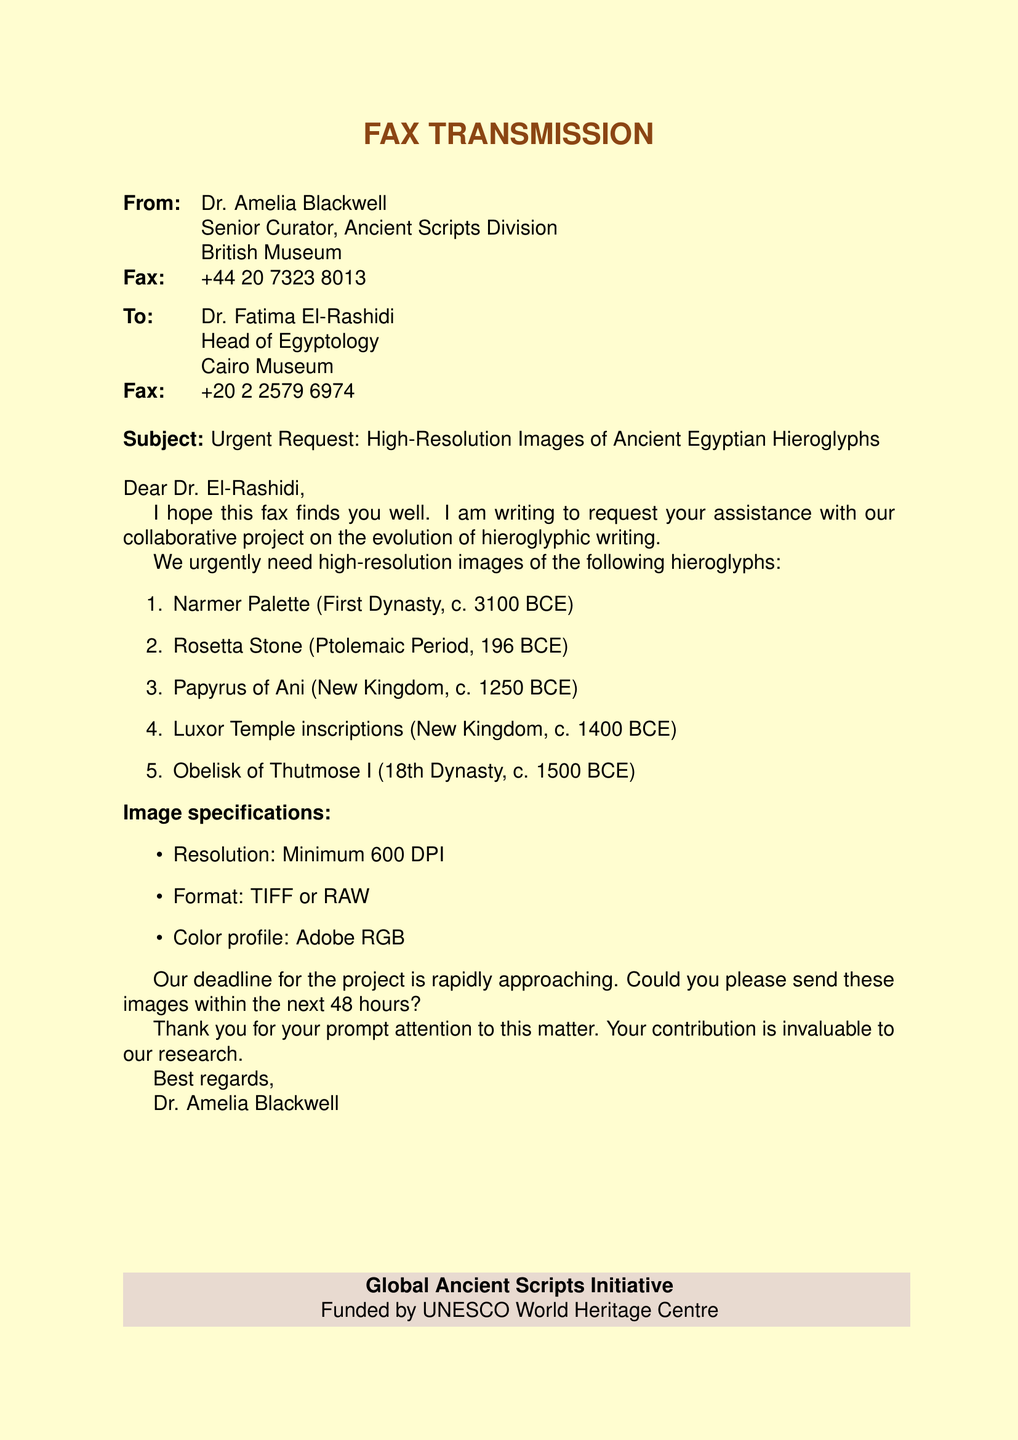What is the subject of the fax? The subject line indicates the main topic being discussed in the fax, which is an urgent request for images.
Answer: Urgent Request: High-Resolution Images of Ancient Egyptian Hieroglyphs Who is the sender of the fax? The sender's name and title are listed at the beginning of the document, indicating who is making the request.
Answer: Dr. Amelia Blackwell What is the requested resolution for the images? The document specifies a minimum requirement for image quality in terms of resolution.
Answer: Minimum 600 DPI Which ancient artifact is associated with the First Dynasty? The list of hieroglyphs includes specific artifacts and their historical contexts, indicating their significance.
Answer: Narmer Palette How many hieroglyphs are mentioned in the request? The number of items in the enumerated list denotes the total request made by the sender.
Answer: Five What is the deadline for sending the images? The deadline for the images is explicitly stated in the request, indicating urgency.
Answer: Within the next 48 hours Which color profile is requested for the images? The specific color profile requirement is mentioned in the image specifications and is critical for image quality.
Answer: Adobe RGB What organization funded the Global Ancient Scripts Initiative? The footer indicates who has provided the funding for the initiative associated with the fax's content.
Answer: UNESCO World Heritage Centre What is the title of the recipient of the fax? The title of the recipient reveals their role and responsibility related to the subject matter discussed.
Answer: Head of Egyptology 